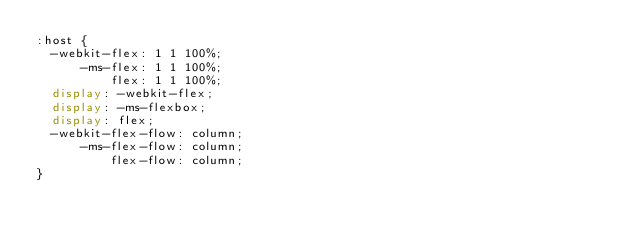Convert code to text. <code><loc_0><loc_0><loc_500><loc_500><_CSS_>:host {
  -webkit-flex: 1 1 100%;
      -ms-flex: 1 1 100%;
          flex: 1 1 100%;
  display: -webkit-flex;
  display: -ms-flexbox;
  display: flex;
  -webkit-flex-flow: column;
      -ms-flex-flow: column;
          flex-flow: column;
}
</code> 